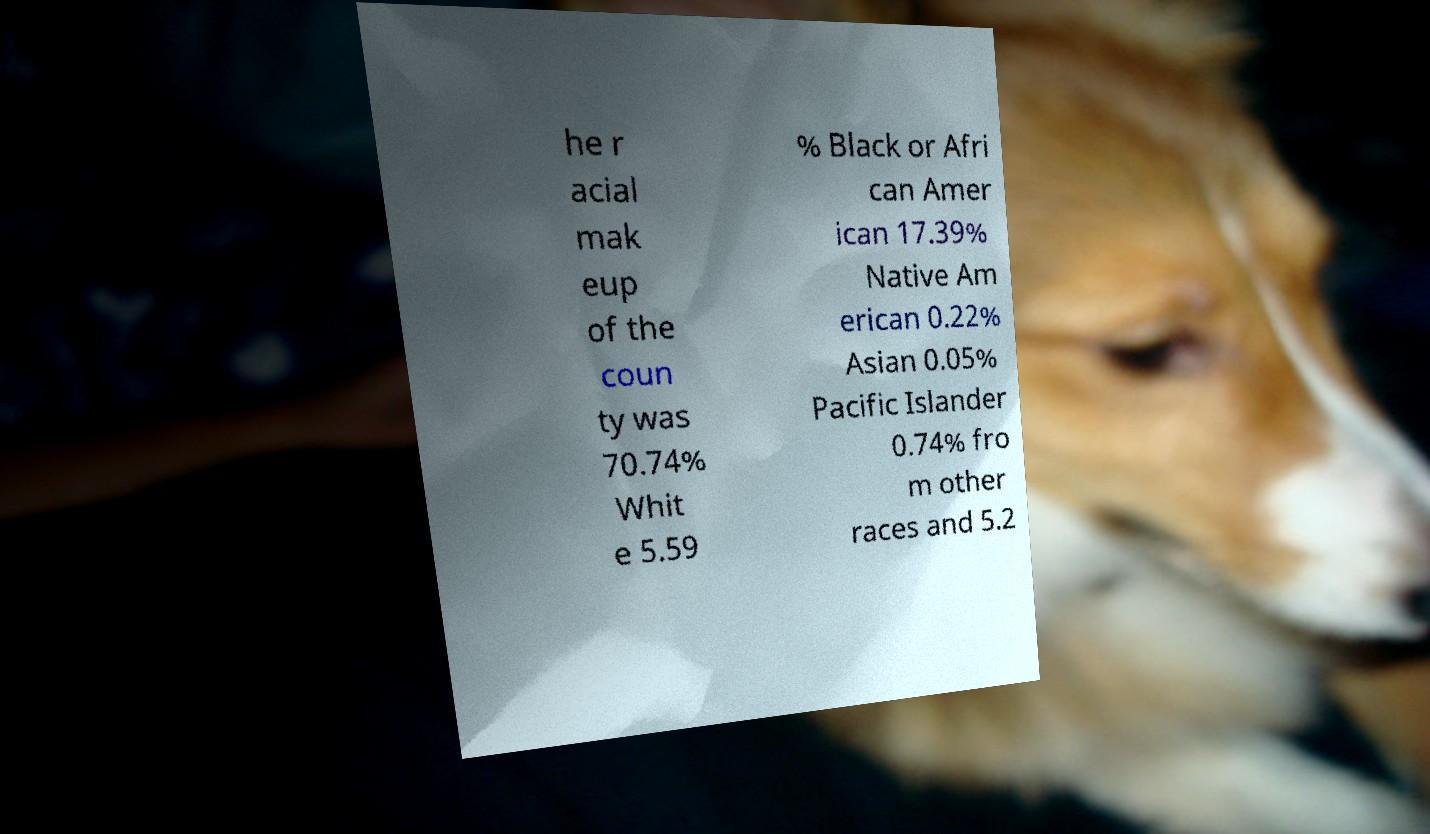Please read and relay the text visible in this image. What does it say? he r acial mak eup of the coun ty was 70.74% Whit e 5.59 % Black or Afri can Amer ican 17.39% Native Am erican 0.22% Asian 0.05% Pacific Islander 0.74% fro m other races and 5.2 